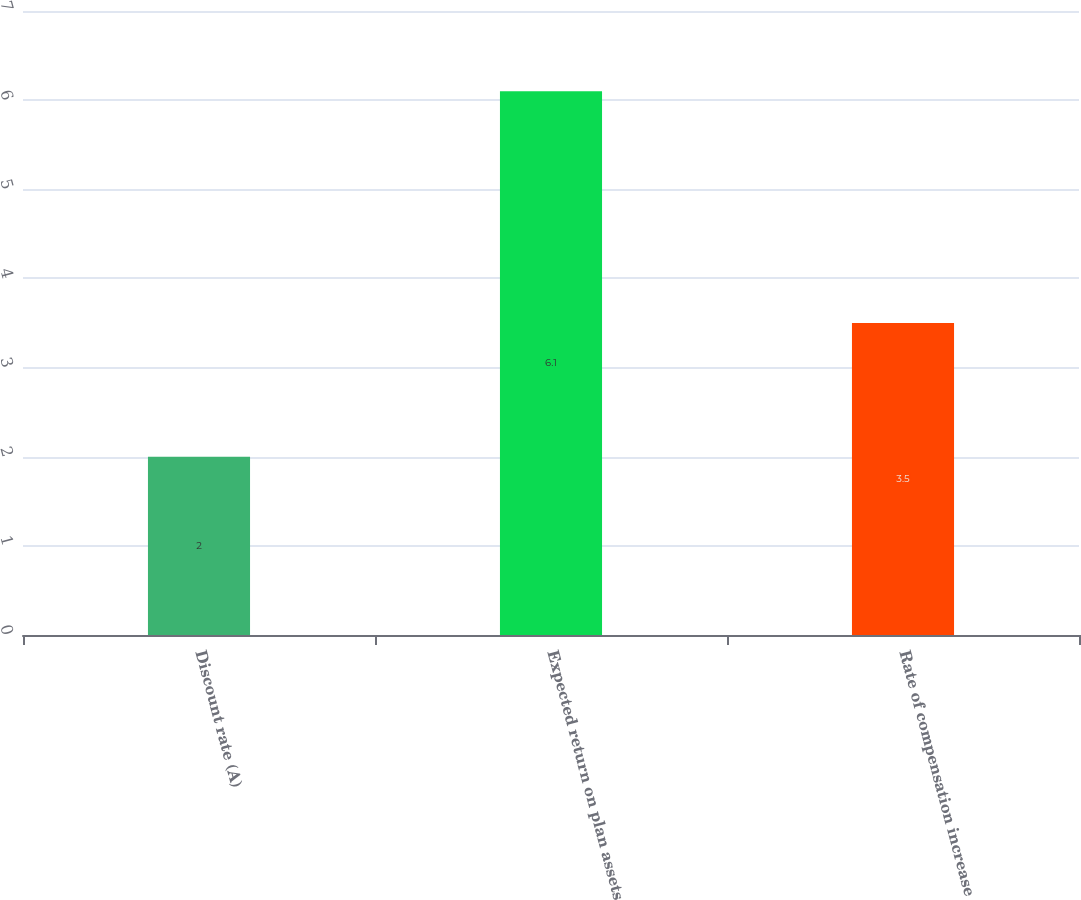Convert chart. <chart><loc_0><loc_0><loc_500><loc_500><bar_chart><fcel>Discount rate (A)<fcel>Expected return on plan assets<fcel>Rate of compensation increase<nl><fcel>2<fcel>6.1<fcel>3.5<nl></chart> 